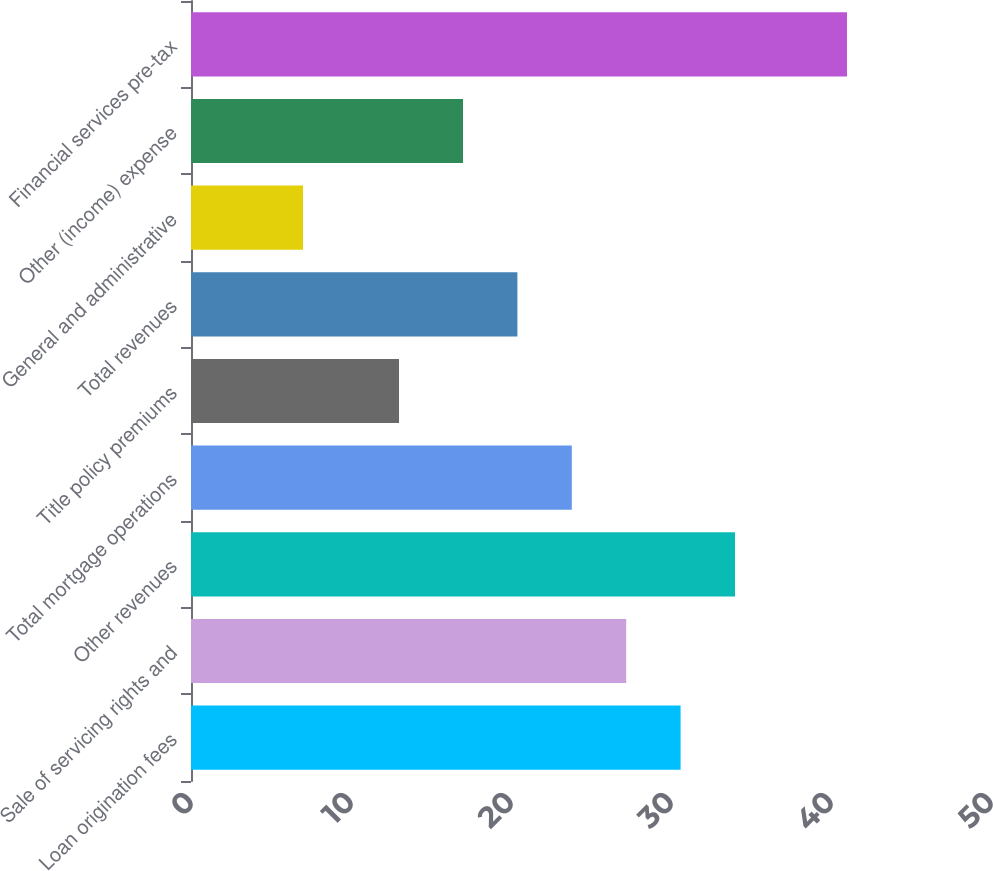<chart> <loc_0><loc_0><loc_500><loc_500><bar_chart><fcel>Loan origination fees<fcel>Sale of servicing rights and<fcel>Other revenues<fcel>Total mortgage operations<fcel>Title policy premiums<fcel>Total revenues<fcel>General and administrative<fcel>Other (income) expense<fcel>Financial services pre-tax<nl><fcel>30.6<fcel>27.2<fcel>34<fcel>23.8<fcel>13<fcel>20.4<fcel>7<fcel>17<fcel>41<nl></chart> 